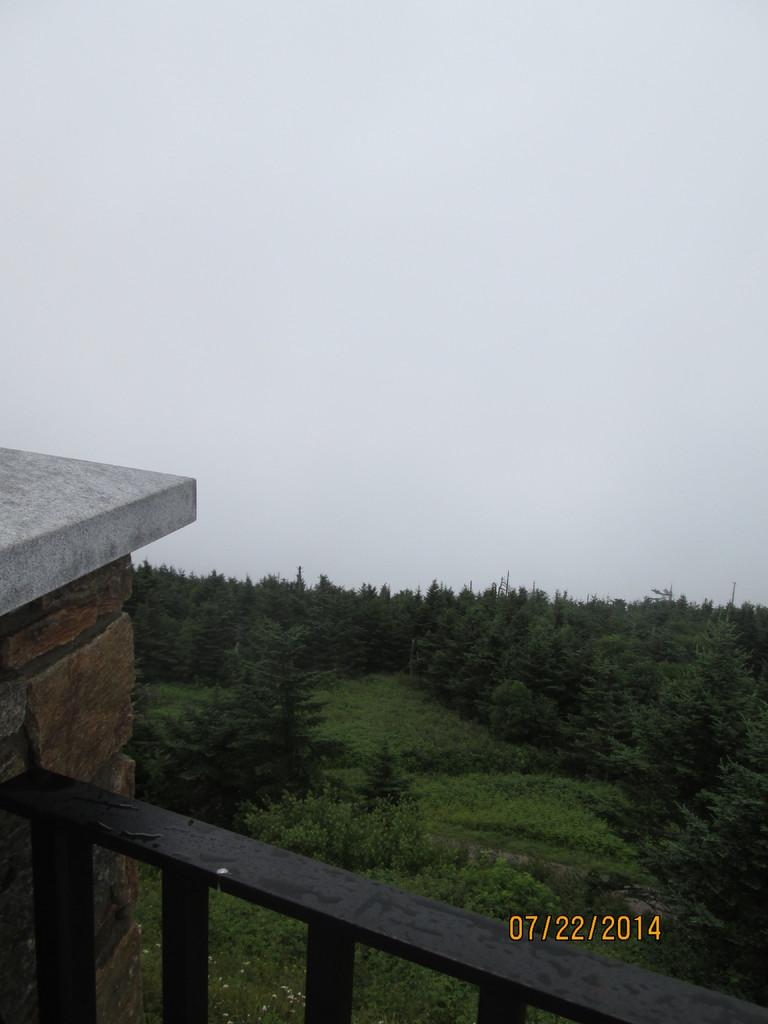What type of natural vegetation can be seen in the image? There are trees in the image. What is the color of the railing in the image? The railing in the image is black. Is there any text or information on the image? Yes, there is a date on the picture, which is in yellow color. What can be seen in the background of the image? There is a sky visible in the background of the image. What type of comb is used by the trees in the image? There is no comb present in the image, as trees do not use combs. What fact can be determined about the quill in the image? There is no quill present in the image, so no fact can be determined about it. 